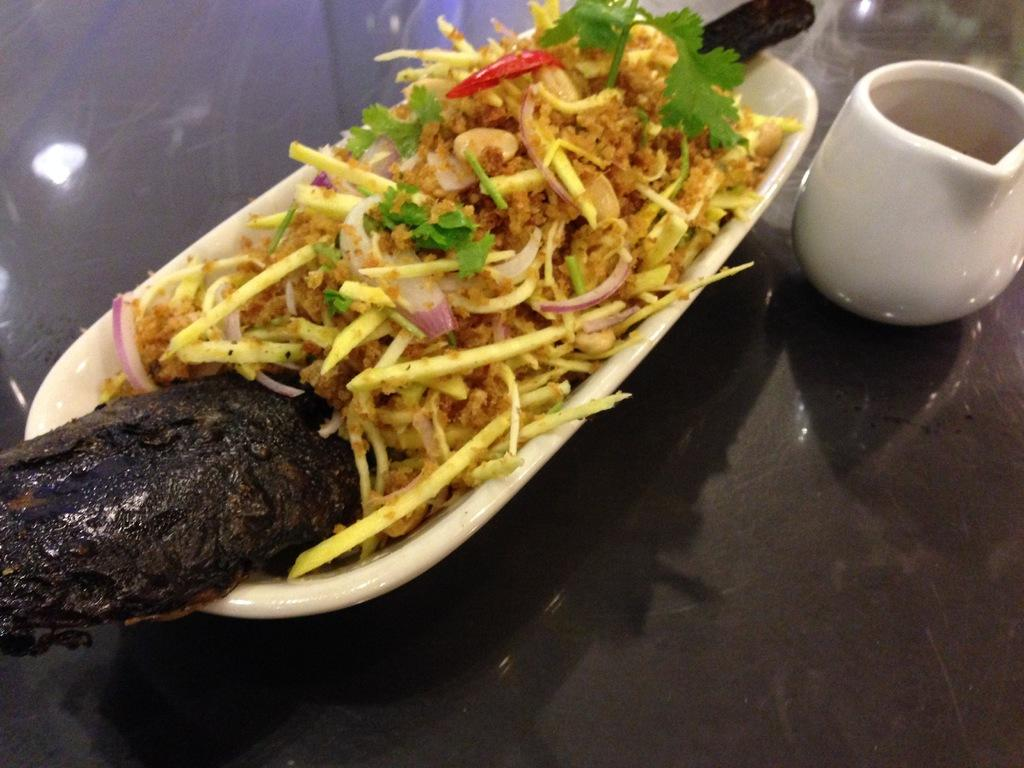What is in the bowl that is visible in the image? There is a bowl with food in the image. What other item can be seen in the image besides the bowl? There is a cup on the right side of the image. What is the color of the surface on which the bowl and cup are placed? The bowl and cup are placed on a black surface. What type of art is displayed on the wall in the image? There is no wall or art present in the image; it only features a bowl with food, a cup, and a black surface. 